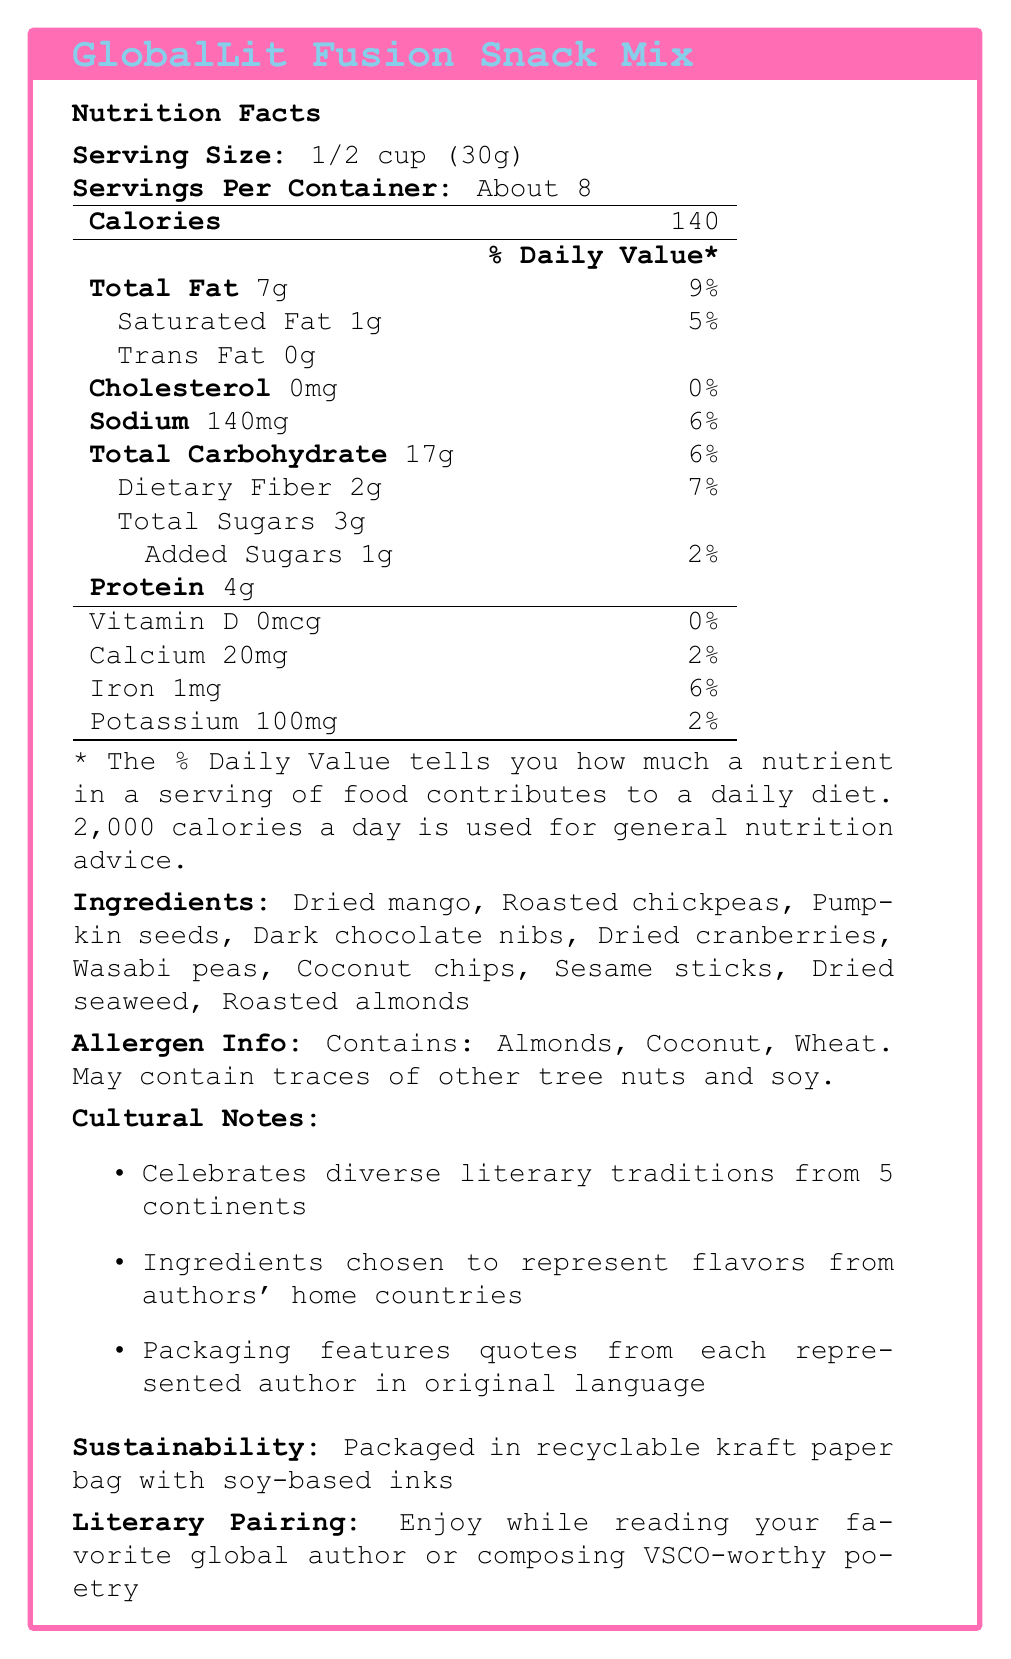What is the serving size for the GlobalLit Fusion Snack Mix? The serving size is explicitly stated as 1/2 cup (30g) in the Nutrition Facts.
Answer: 1/2 cup (30g) How many calories are there per serving? The Nutrition Facts table lists 140 calories per serving.
Answer: 140 calories What is the total fat content and its daily value percentage for a serving? The document states that the total fat content is 7g, which corresponds to 9% of the daily value.
Answer: 7g, 9% List three ingredients that are inspired by authors mentioned in the document. The ingredients section lists numerous ingredients inspired by authors, including Dried mango (Gabriel García Márquez), Roasted chickpeas (Orhan Pamuk), and Dark chocolate nibs (Emily Brontë).
Answer: Dried mango, Roasted chickpeas, Dark chocolate nibs Which ingredient is associated with Jules Verne? According to the ingredients section, dried seaweed is a tribute to Jules Verne.
Answer: Dried seaweed Which statement best describes the allergen information for the snack mix?
A. Contains Almonds, Coconut, Wheat, and Soy.
B. Contains Almonds, Coconut, Wheat. May contain traces of other tree nuts and soy.
C. Contains Almonds, Soy, and Wheat.
D. Contains tree nuts, wheat, and dried seaweed. The Allergen Info states, "Contains: Almonds, Coconut, Wheat. May contain traces of other tree nuts and soy."
Answer: B What does the snack mix’s sustainability note mention about its packaging? 
A. It's packaged in recyclable kraft paper bag with soy-based inks.
B. It's delivered in non-recyclable plastic packaging.
C. It uses biodegradable plastic exclusively.
D. It's wrapped in aluminum foil. The sustainability section notes that the snack mix is packaged in recyclable kraft paper bag with soy-based inks.
Answer: A Does the GlobalLit Fusion Snack Mix contain any cholesterol? The Nutrition Facts table lists 0mg of cholesterol per serving, indicating that it contains no cholesterol.
Answer: No Summarize the main idea of the GlobalLit Fusion Snack Mix document. The document provides detailed nutritional information, lists literary-inspired ingredients, outlines allergen data, describes sustainable packaging practices, and suggests a cultural-literary pairing for enjoyment.
Answer: The GlobalLit Fusion Snack Mix is a culturally inspired snack featuring ingredients that pay homage to various global literary figures. It is nutritionally detailed, provides allergen information, notes sustainability in packaging, and highlights a cultural and literary thematic pairing. How many servings are in one container of the GlobalLit Fusion Snack Mix? The document states that there are about 8 servings per container.
Answer: About 8 How much sodium is in a serving of the snack mix and what is its percent daily value? The document lists sodium content as 140mg per serving, which corresponds to 6% of the daily value.
Answer: 140mg, 6% What is the dietary fiber content in a serving of the snack mix? The Nutrition Facts table shows that each serving contains 2g of dietary fiber.
Answer: 2g List one of the cultural notes mentioned in the document. The cultural notes list several items, one of which is the celebration of diverse literary traditions from 5 continents.
Answer: Celebrates diverse literary traditions from 5 continents Who is the ingredient 'Wasabi Peas' inspired by? The ingredients section shows that wasabi peas are a nod to Haruki Murakami.
Answer: Haruki Murakami What are the potassium and vitamin D contents per serving? The Nutrition Facts table states that each serving contains 100mg of potassium and 0mcg of vitamin D.
Answer: Potassium: 100mg, Vitamin D: 0mcg Is there enough information to determine the manufacturing location of the GlobalLit Fusion Snack Mix? The document does not provide any details regarding the manufacturing location of the snack mix.
Answer: Not enough information 